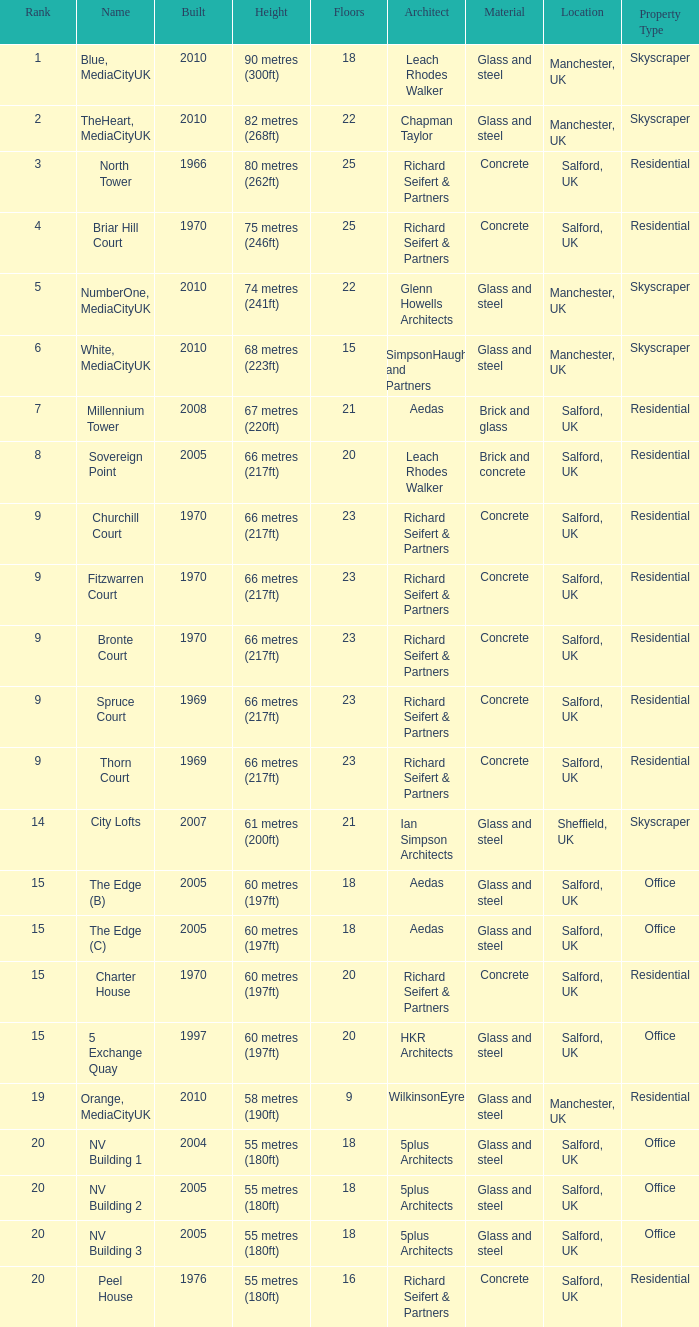What is the lowest Built, when Floors is greater than 23, and when Rank is 3? 1966.0. 